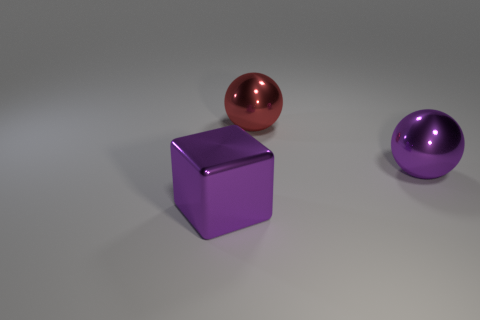Add 3 yellow metal objects. How many objects exist? 6 Subtract all spheres. How many objects are left? 1 Add 1 small blue metallic cylinders. How many small blue metallic cylinders exist? 1 Subtract 0 blue balls. How many objects are left? 3 Subtract all large cubes. Subtract all cubes. How many objects are left? 1 Add 3 large red balls. How many large red balls are left? 4 